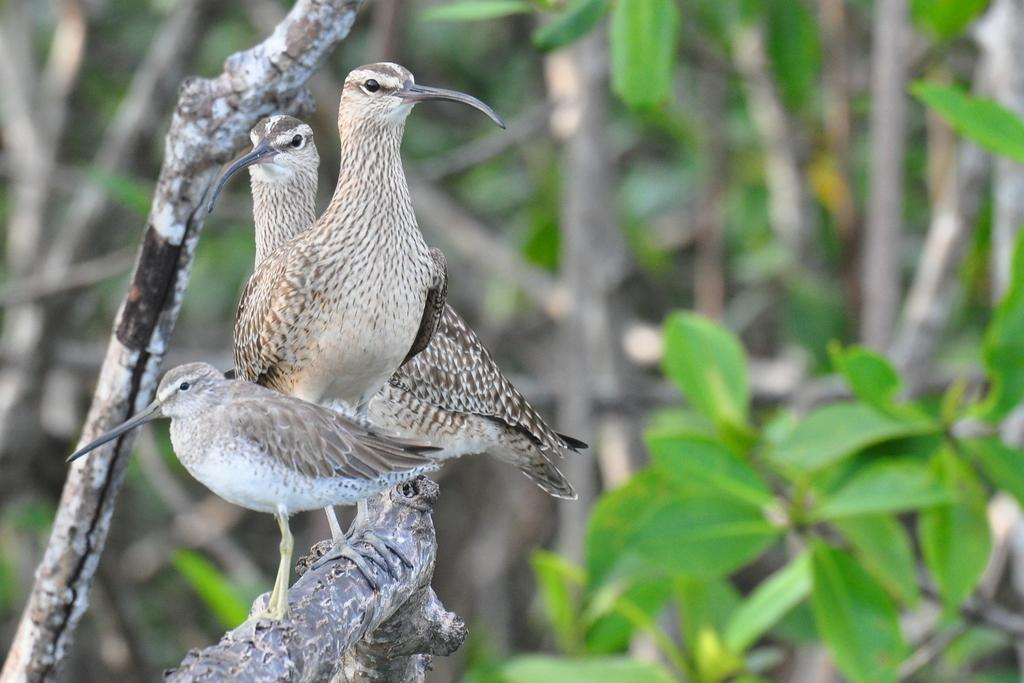How many birds are visible in the image? There are three birds on a branch in the image. What can be seen in the background of the image? There are trees and leaves in the background of the image. What type of wax is being used to celebrate the birthday in the image? There is no wax or birthday celebration present in the image; it features three birds on a branch with trees and leaves in the background. 